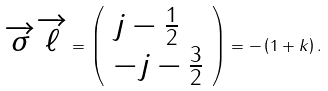<formula> <loc_0><loc_0><loc_500><loc_500>\overrightarrow { \sigma } \overrightarrow { \ell } = \left ( \begin{array} { l } j - \frac { 1 } { 2 } \\ - j - \frac { 3 } { 2 } \end{array} \right ) = - \left ( 1 + k \right ) .</formula> 